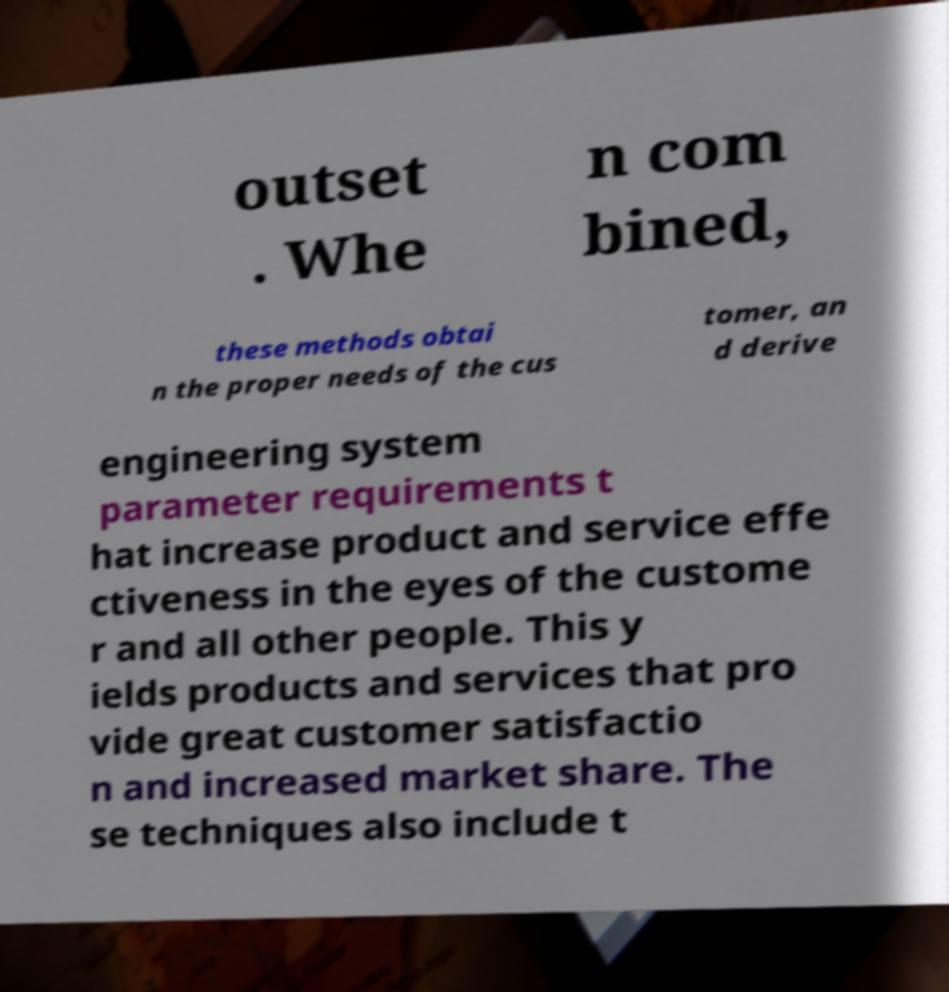For documentation purposes, I need the text within this image transcribed. Could you provide that? outset . Whe n com bined, these methods obtai n the proper needs of the cus tomer, an d derive engineering system parameter requirements t hat increase product and service effe ctiveness in the eyes of the custome r and all other people. This y ields products and services that pro vide great customer satisfactio n and increased market share. The se techniques also include t 